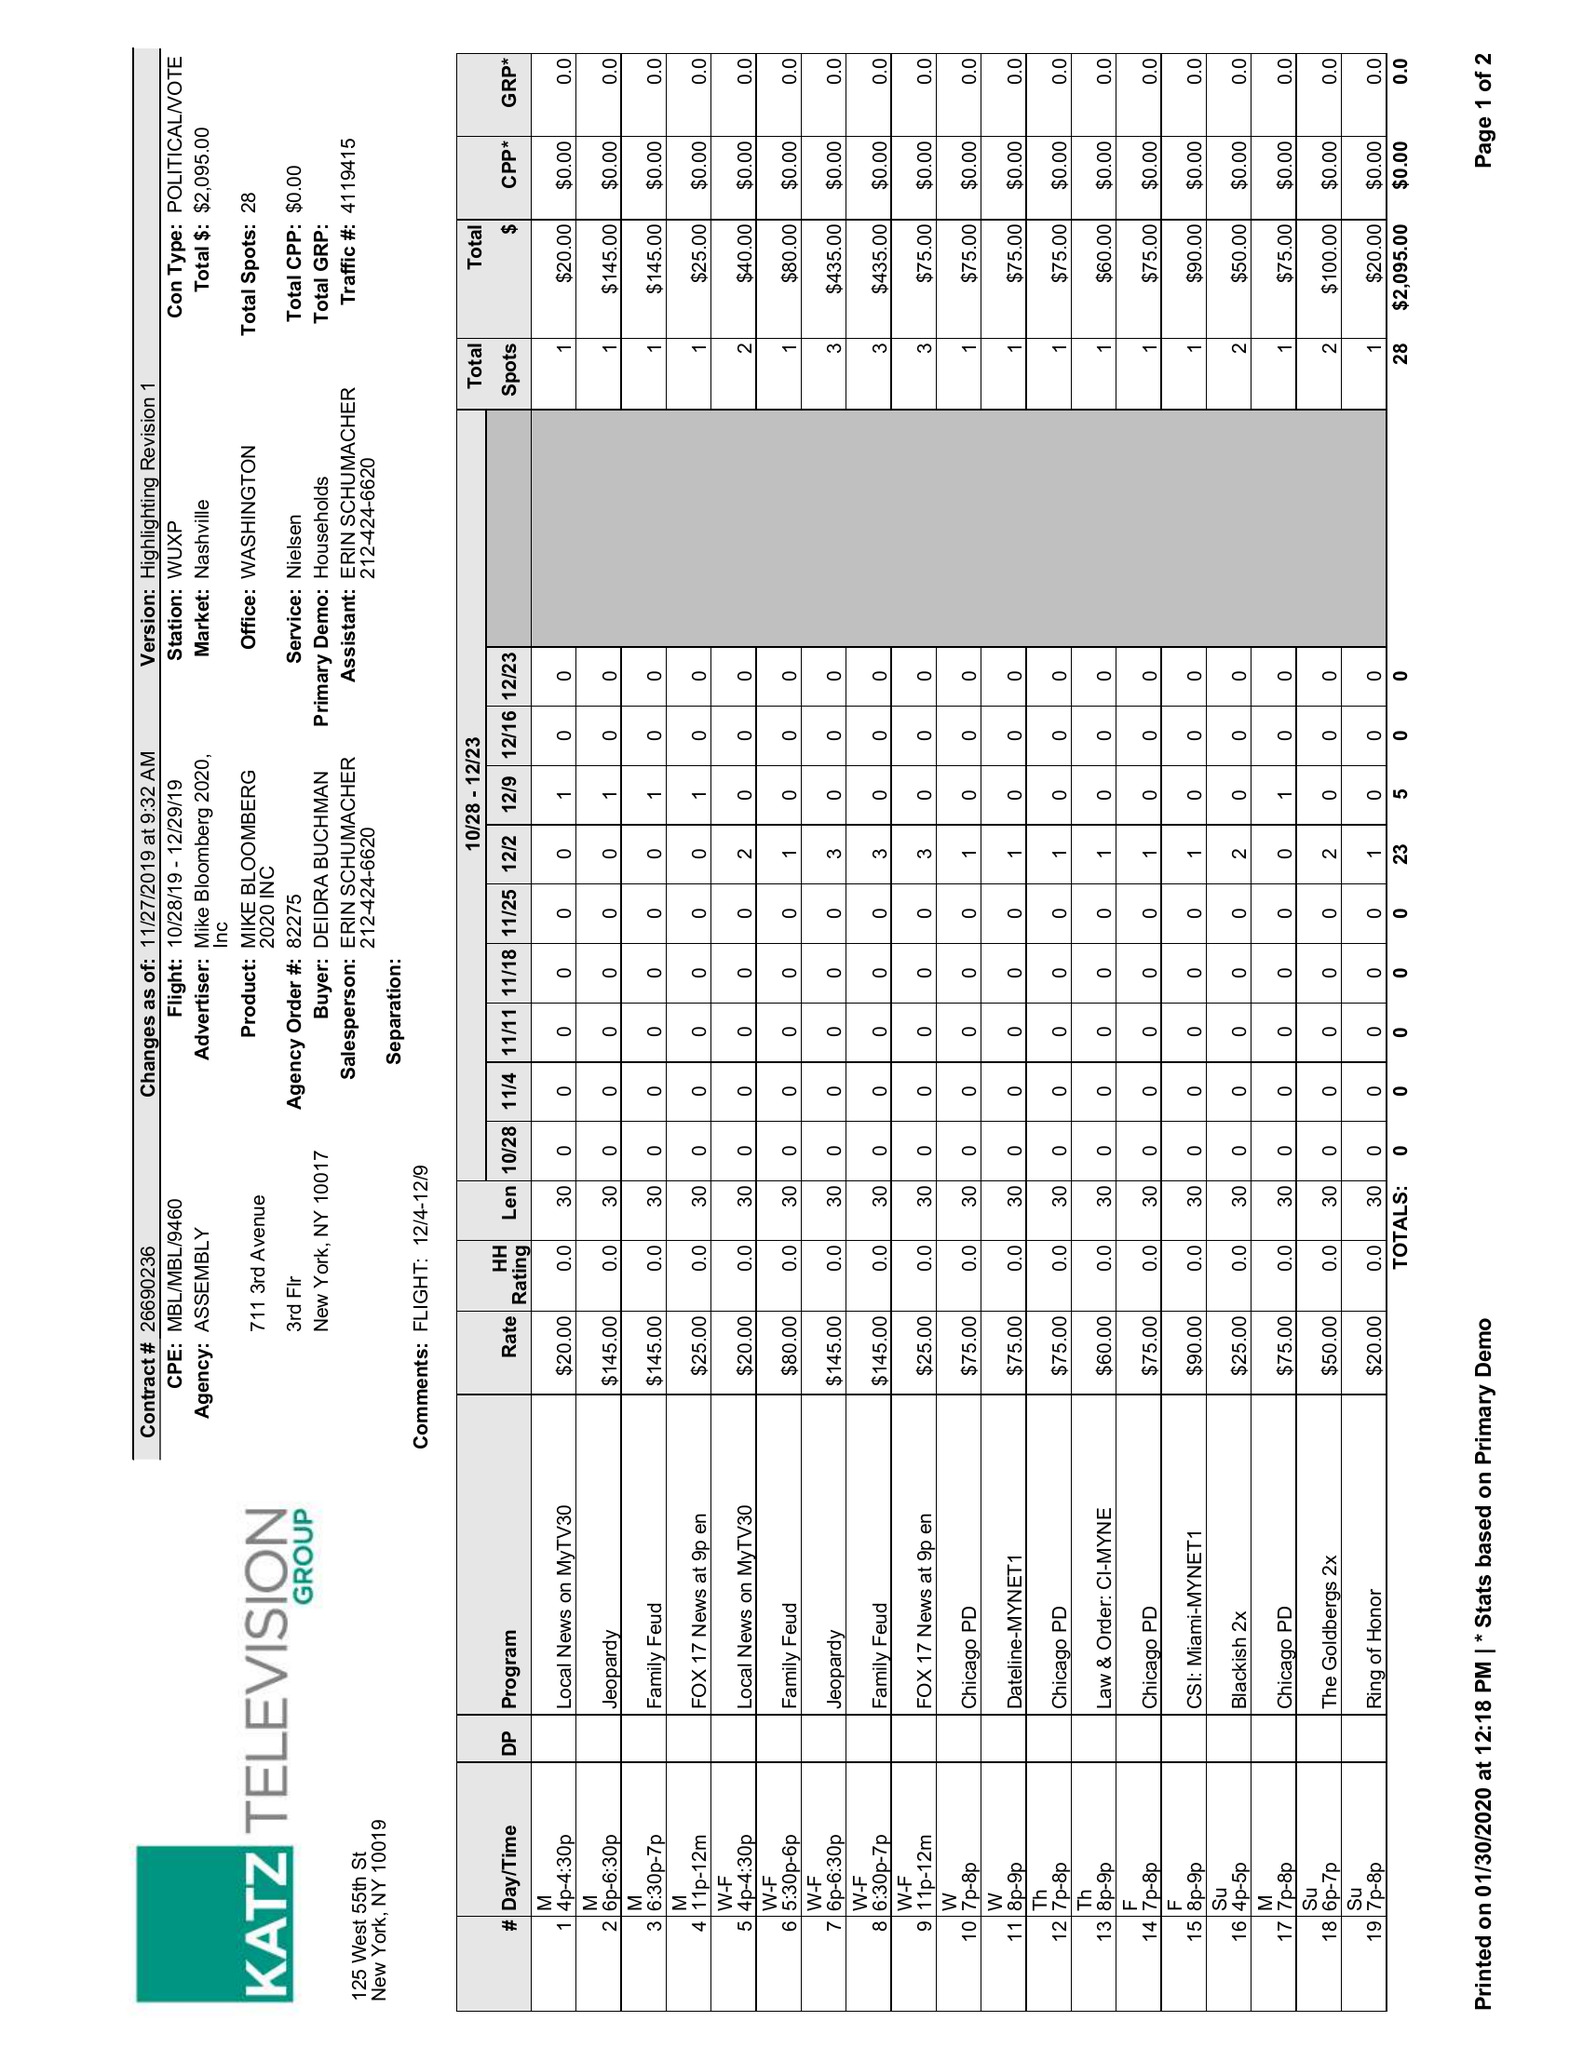What is the value for the advertiser?
Answer the question using a single word or phrase. MIKE BLOOMBERG 2020, INC 